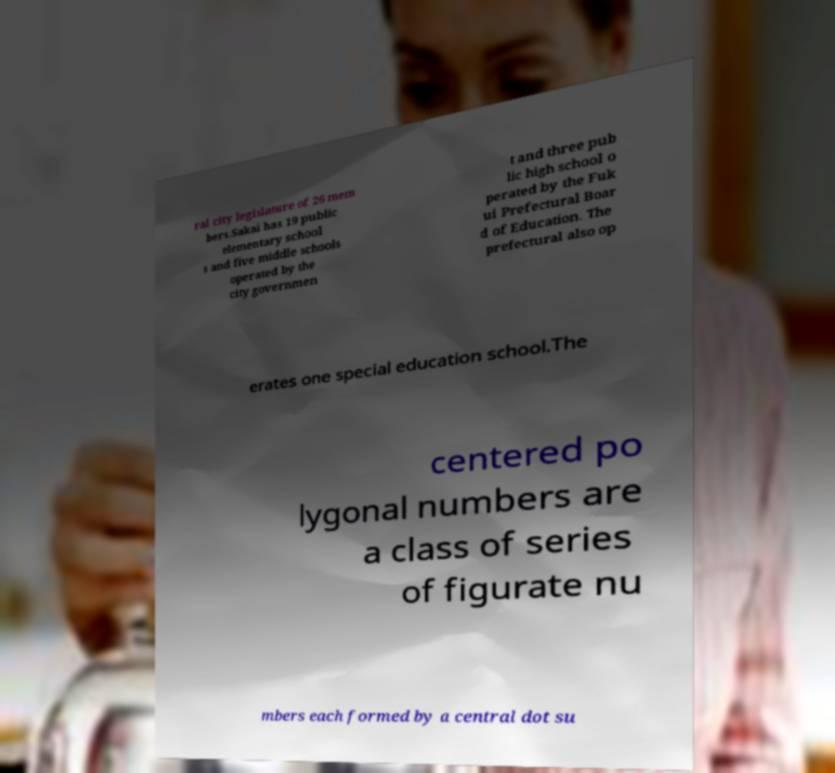I need the written content from this picture converted into text. Can you do that? ral city legislature of 26 mem bers.Sakai has 19 public elementary school s and five middle schools operated by the city governmen t and three pub lic high school o perated by the Fuk ui Prefectural Boar d of Education. The prefectural also op erates one special education school.The centered po lygonal numbers are a class of series of figurate nu mbers each formed by a central dot su 